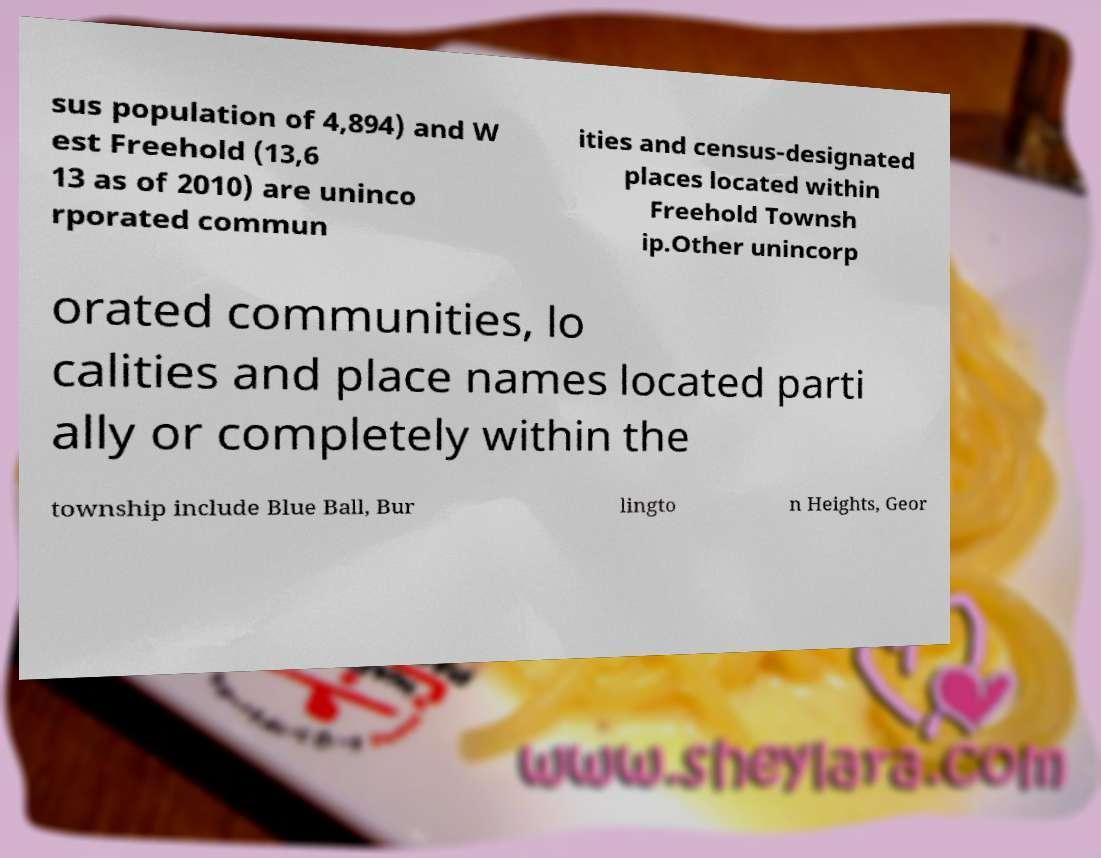What messages or text are displayed in this image? I need them in a readable, typed format. sus population of 4,894) and W est Freehold (13,6 13 as of 2010) are uninco rporated commun ities and census-designated places located within Freehold Townsh ip.Other unincorp orated communities, lo calities and place names located parti ally or completely within the township include Blue Ball, Bur lingto n Heights, Geor 